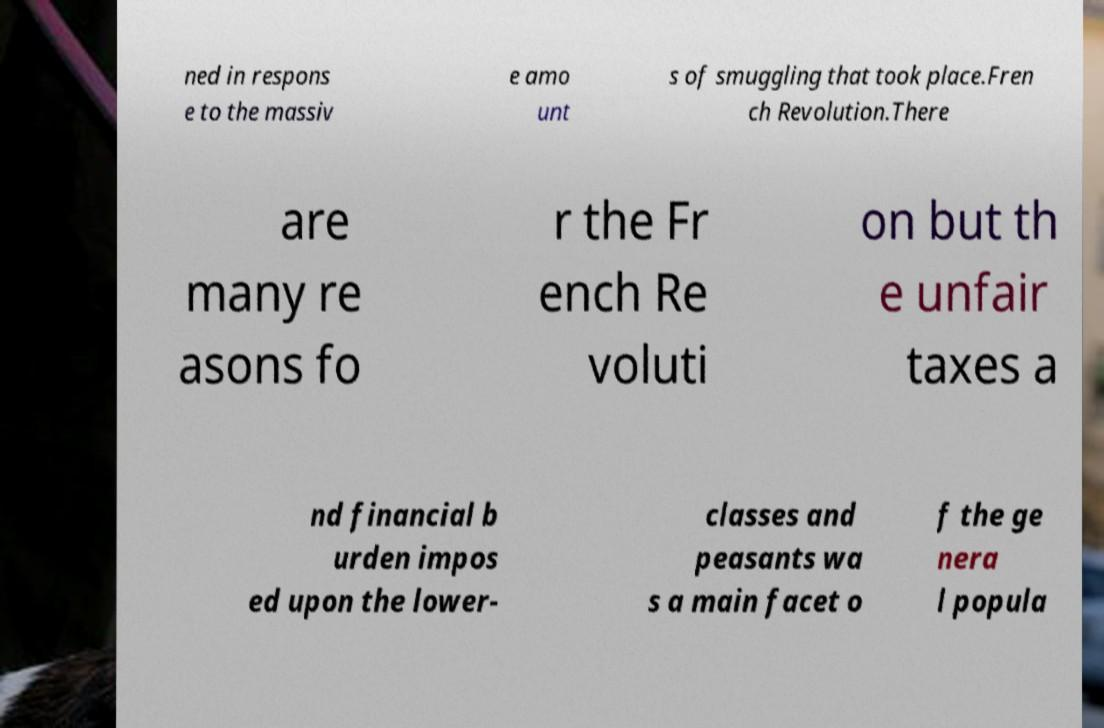Please read and relay the text visible in this image. What does it say? ned in respons e to the massiv e amo unt s of smuggling that took place.Fren ch Revolution.There are many re asons fo r the Fr ench Re voluti on but th e unfair taxes a nd financial b urden impos ed upon the lower- classes and peasants wa s a main facet o f the ge nera l popula 